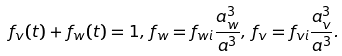Convert formula to latex. <formula><loc_0><loc_0><loc_500><loc_500>f _ { v } ( t ) + f _ { w } ( t ) = 1 , \, f _ { w } = f _ { w i } \frac { a _ { w } ^ { 3 } } { a ^ { 3 } } , \, f _ { v } = f _ { v i } \frac { a _ { v } ^ { 3 } } { a ^ { 3 } } .</formula> 